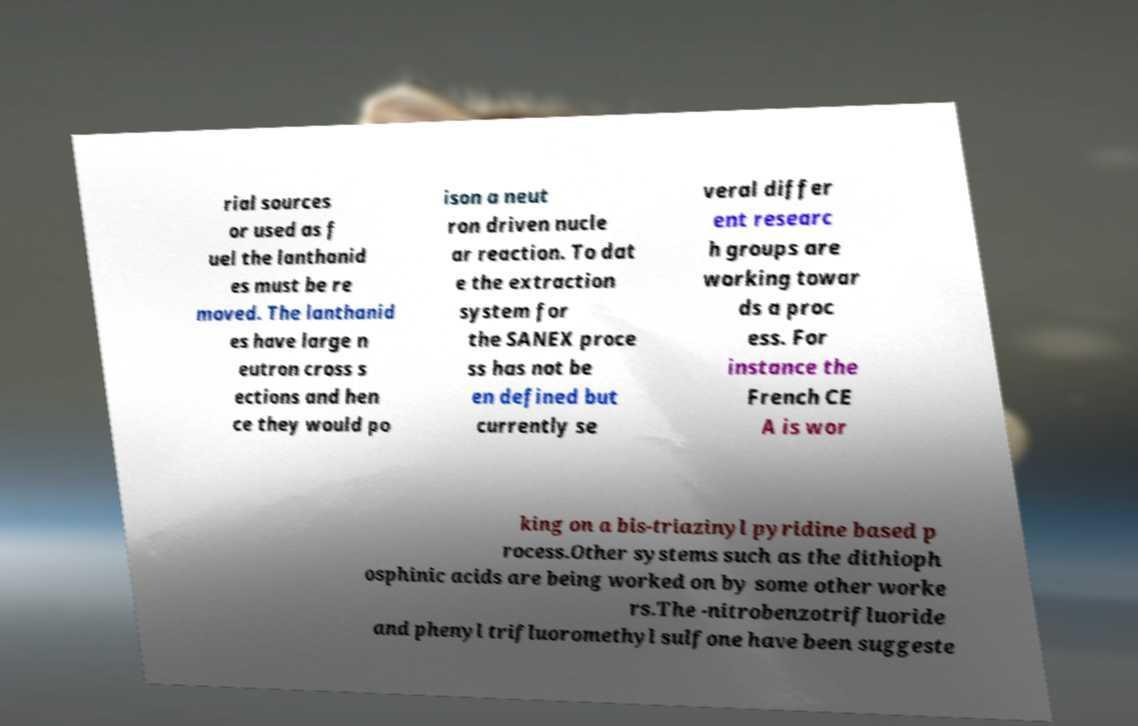For documentation purposes, I need the text within this image transcribed. Could you provide that? rial sources or used as f uel the lanthanid es must be re moved. The lanthanid es have large n eutron cross s ections and hen ce they would po ison a neut ron driven nucle ar reaction. To dat e the extraction system for the SANEX proce ss has not be en defined but currently se veral differ ent researc h groups are working towar ds a proc ess. For instance the French CE A is wor king on a bis-triazinyl pyridine based p rocess.Other systems such as the dithioph osphinic acids are being worked on by some other worke rs.The -nitrobenzotrifluoride and phenyl trifluoromethyl sulfone have been suggeste 